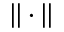Convert formula to latex. <formula><loc_0><loc_0><loc_500><loc_500>| | \cdot | |</formula> 